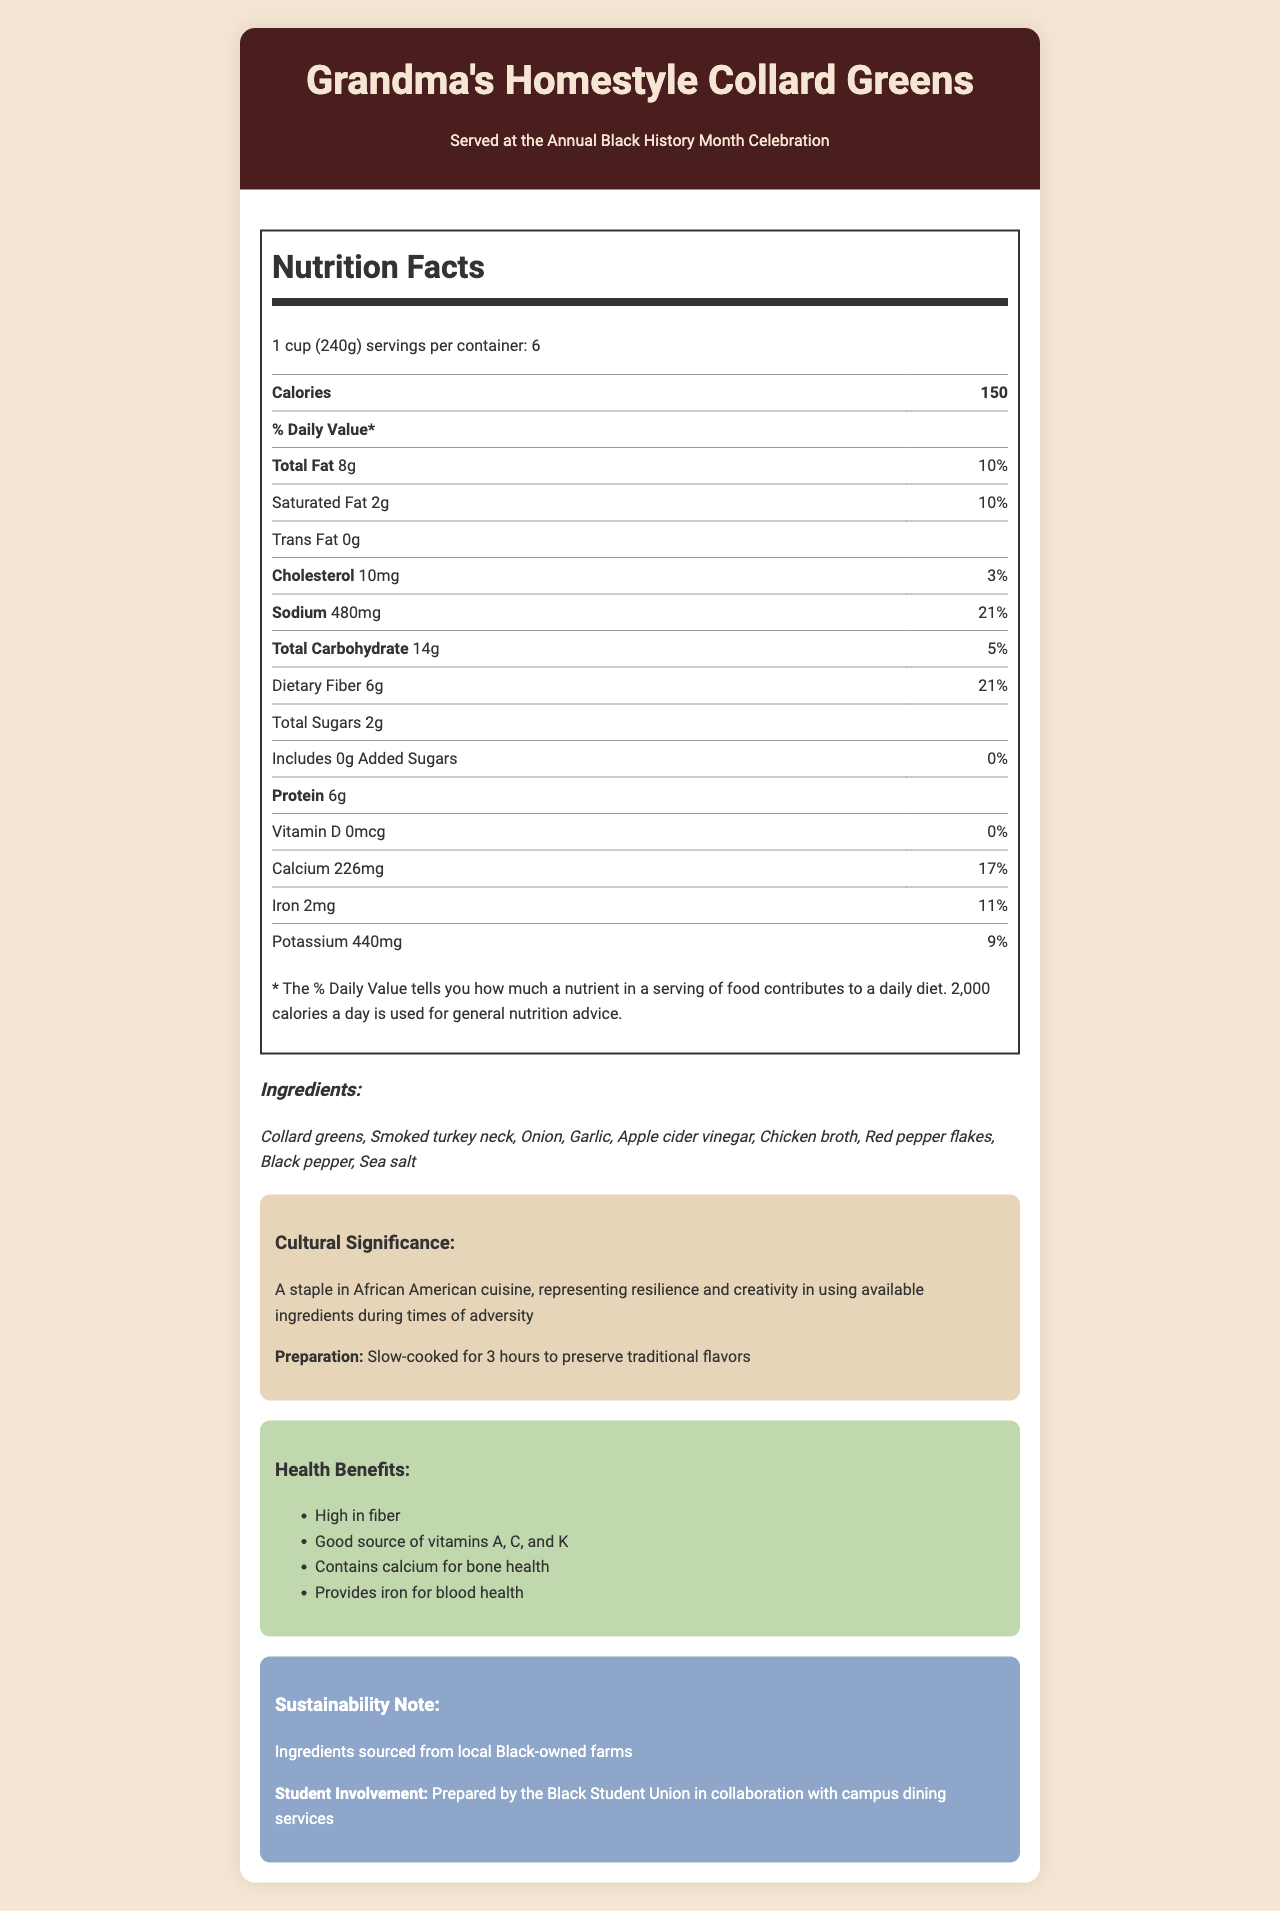what is the serving size? The serving size is listed at the top of the Nutrition Facts section, and it is described as "1 cup (240g)."
Answer: 1 cup (240g) how many servings per container are there? The number of servings per container is listed as 6 in the Nutrition Facts section beneath the serving size.
Answer: 6 how much total fat is in one serving? The amount of total fat per serving is listed as 8g in the Nutrition Facts section.
Answer: 8g what percentage of the daily value does the sodium content in one serving represent? The sodium content per serving is 480mg, which is 21% of the daily value, as shown in the Nutrition Facts section.
Answer: 21% what ingredients are used in Grandma's Homestyle Collard Greens? The ingredients are listed in the document's ingredients section under "Ingredients."
Answer: Collard greens, Smoked turkey neck, Onion, Garlic, Apple cider vinegar, Chicken broth, Red pepper flakes, Black pepper, Sea salt which health benefit is NOT mentioned in the document? A. High in fiber B. Good source of vitamin C C. High in omega-3 fatty acids D. Contains calcium for bone health The health benefits listed include high in fiber, good source of vitamins A, C, and K, and contains calcium for bone health, but not high in omega-3 fatty acids.
Answer: C what is the cultural significance of this dish according to the document? A. Reflects modern culinary techniques B. Represents resilience and creativity during adversity C. Known for being the most popular dish in African American cuisine D. Highlights the influence of Western cuisine The cultural significance section states that this dish represents resilience and creativity in using available ingredients during times of adversity.
Answer: B are allergens present in Grandma's Homestyle Collard Greens? The allergens section states that there are no allergens present in Grandma's Homestyle Collard Greens.
Answer: No is the preparation method designed to preserve traditional flavors? According to the document, the preparation involves slow-cooking for 3 hours to preserve traditional flavors.
Answer: Yes describe the main idea of the document The document contains various sections, each describing different aspects of the dish, including its nutritional content, cultural relevance, health benefits, and preparation details, emphasizing its traditional roots and community engagement.
Answer: The document provides detailed nutritional information for Grandma's Homestyle Collard Greens, served at a cultural event. It highlights the serving size, calories, and nutritional content per serving. Moreover, it elaborates on the dish's ingredients, allergens, cultural significance, preparation method, health benefits, sustainability note, and student involvement in preparation. how much calcium does one serving contain? The Nutrition Facts section lists the amount of calcium per serving as 226mg.
Answer: 226mg what is the preparation time for this dish? The preparation time is listed under the cultural significance section, stating that it's slow-cooked for 3 hours.
Answer: 3 hours how many grams of dietary fiber are in one serving? The Nutrition Facts section lists the amount of dietary fiber per serving as 6g.
Answer: 6g how are the ingredients for this dish sourced according to the document? The sustainability note specifies that the ingredients are sourced from local Black-owned farms.
Answer: From local Black-owned farms what percentage of daily iron is provided by one serving of this dish? The Nutrition Facts section lists the percentage of daily value for iron at 11%.
Answer: 11% how many grams of trans fat are in one serving? The amount of trans fat per serving is listed as 0g in the Nutrition Facts section.
Answer: 0g who prepared this dish for the event? The student involvement section specifies that the dish was prepared by the Black Student Union in collaboration with campus dining services.
Answer: Black Student Union in collaboration with campus dining services what is the role of smoked turkey neck in the recipe? The document lists smoked turkey neck as an ingredient, but it does not specify its exact role in the recipe.
Answer: Not enough information what is the amount of protein in one serving? The Nutrition Facts section lists the amount of protein per serving as 6g.
Answer: 6g 